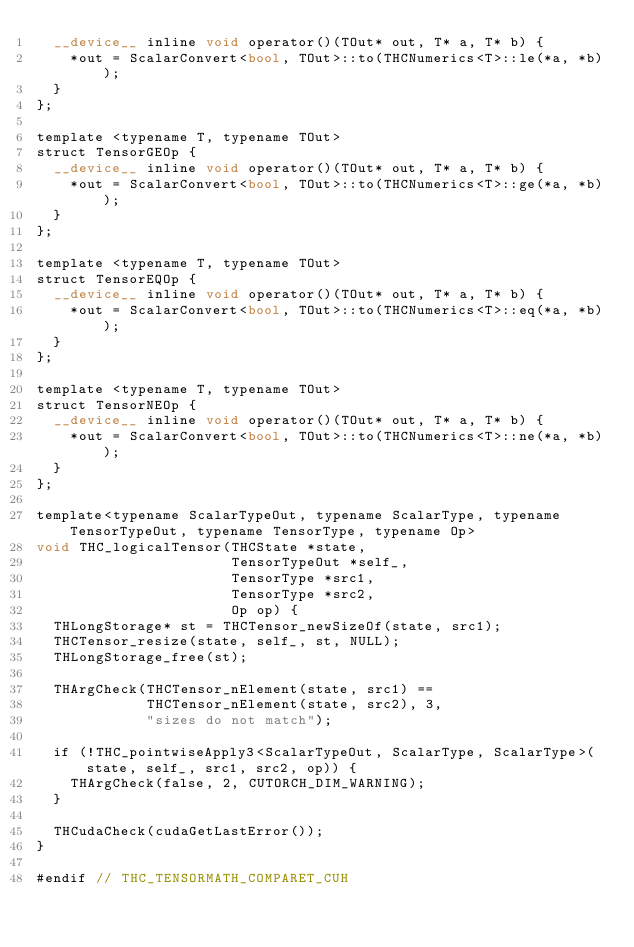<code> <loc_0><loc_0><loc_500><loc_500><_Cuda_>  __device__ inline void operator()(TOut* out, T* a, T* b) {
    *out = ScalarConvert<bool, TOut>::to(THCNumerics<T>::le(*a, *b));
  }
};

template <typename T, typename TOut>
struct TensorGEOp {
  __device__ inline void operator()(TOut* out, T* a, T* b) {
    *out = ScalarConvert<bool, TOut>::to(THCNumerics<T>::ge(*a, *b));
  }
};

template <typename T, typename TOut>
struct TensorEQOp {
  __device__ inline void operator()(TOut* out, T* a, T* b) {
    *out = ScalarConvert<bool, TOut>::to(THCNumerics<T>::eq(*a, *b));
  }
};

template <typename T, typename TOut>
struct TensorNEOp {
  __device__ inline void operator()(TOut* out, T* a, T* b) {
    *out = ScalarConvert<bool, TOut>::to(THCNumerics<T>::ne(*a, *b));
  }
};

template<typename ScalarTypeOut, typename ScalarType, typename TensorTypeOut, typename TensorType, typename Op>
void THC_logicalTensor(THCState *state,
                       TensorTypeOut *self_,
                       TensorType *src1,
                       TensorType *src2,
                       Op op) {
  THLongStorage* st = THCTensor_newSizeOf(state, src1);
  THCTensor_resize(state, self_, st, NULL);
  THLongStorage_free(st);

  THArgCheck(THCTensor_nElement(state, src1) ==
             THCTensor_nElement(state, src2), 3,
             "sizes do not match");

  if (!THC_pointwiseApply3<ScalarTypeOut, ScalarType, ScalarType>(state, self_, src1, src2, op)) {
    THArgCheck(false, 2, CUTORCH_DIM_WARNING);
  }

  THCudaCheck(cudaGetLastError());
}

#endif // THC_TENSORMATH_COMPARET_CUH
</code> 